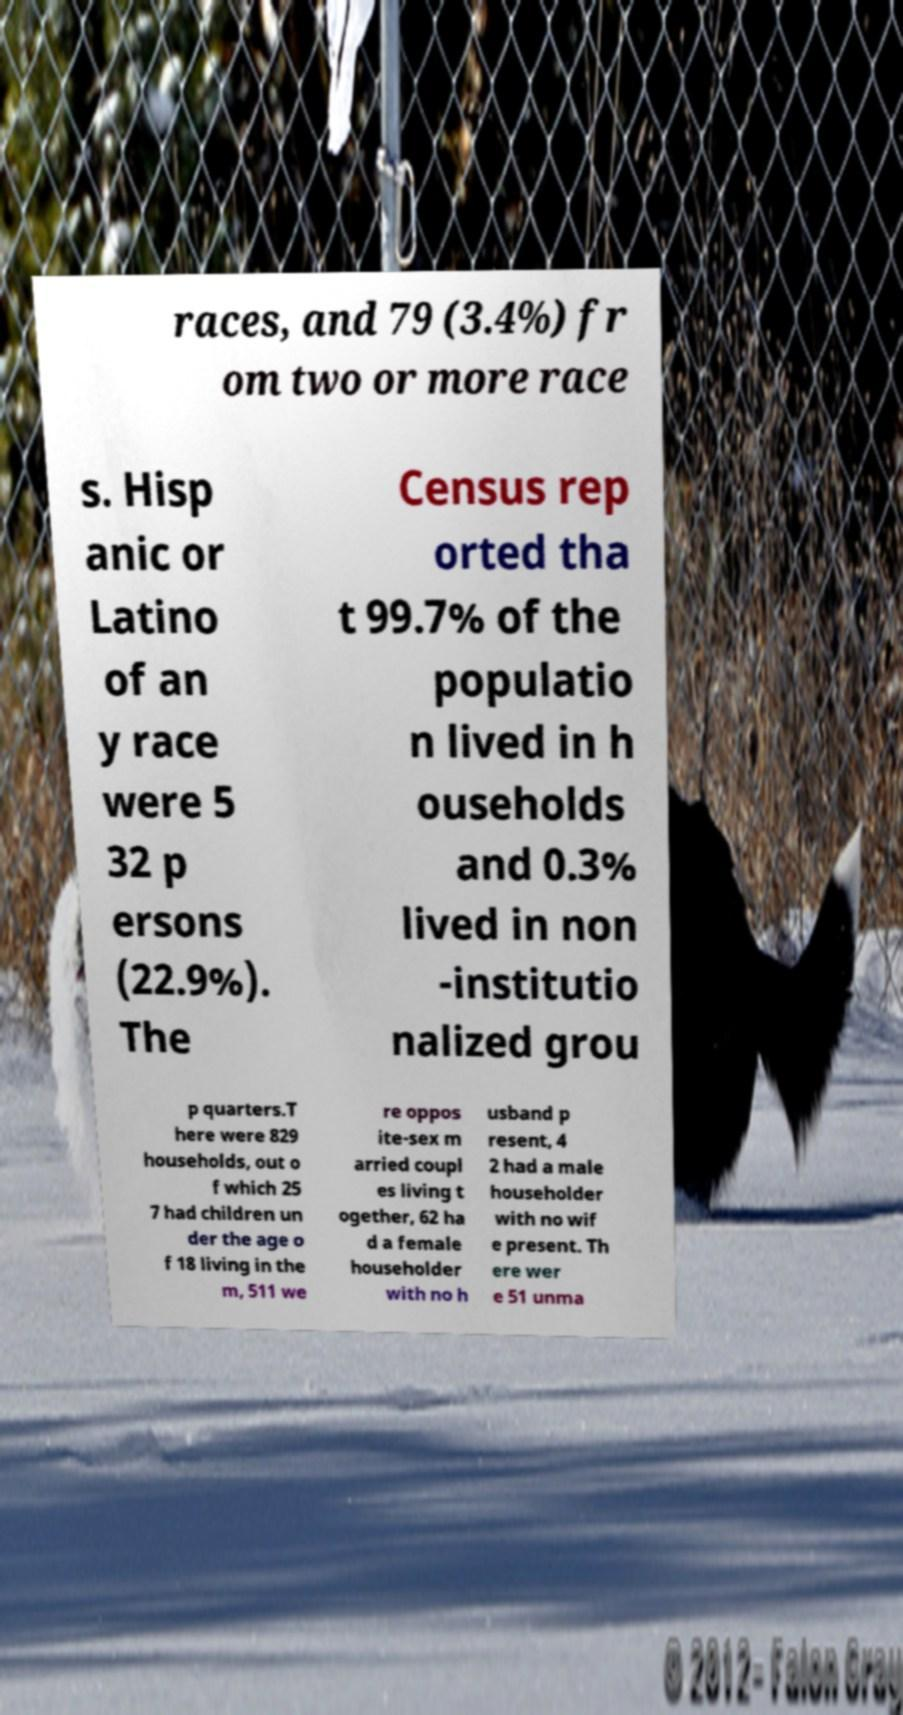Could you assist in decoding the text presented in this image and type it out clearly? races, and 79 (3.4%) fr om two or more race s. Hisp anic or Latino of an y race were 5 32 p ersons (22.9%). The Census rep orted tha t 99.7% of the populatio n lived in h ouseholds and 0.3% lived in non -institutio nalized grou p quarters.T here were 829 households, out o f which 25 7 had children un der the age o f 18 living in the m, 511 we re oppos ite-sex m arried coupl es living t ogether, 62 ha d a female householder with no h usband p resent, 4 2 had a male householder with no wif e present. Th ere wer e 51 unma 